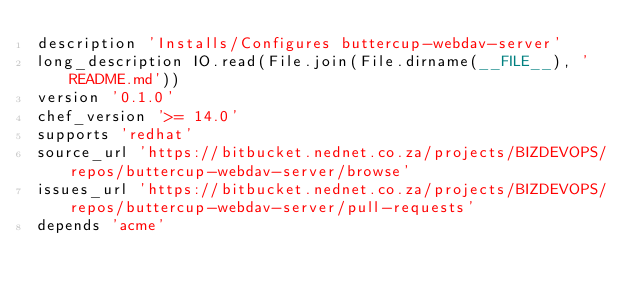<code> <loc_0><loc_0><loc_500><loc_500><_Ruby_>description 'Installs/Configures buttercup-webdav-server'
long_description IO.read(File.join(File.dirname(__FILE__), 'README.md'))
version '0.1.0'
chef_version '>= 14.0'
supports 'redhat'
source_url 'https://bitbucket.nednet.co.za/projects/BIZDEVOPS/repos/buttercup-webdav-server/browse'
issues_url 'https://bitbucket.nednet.co.za/projects/BIZDEVOPS/repos/buttercup-webdav-server/pull-requests'
depends 'acme'
</code> 